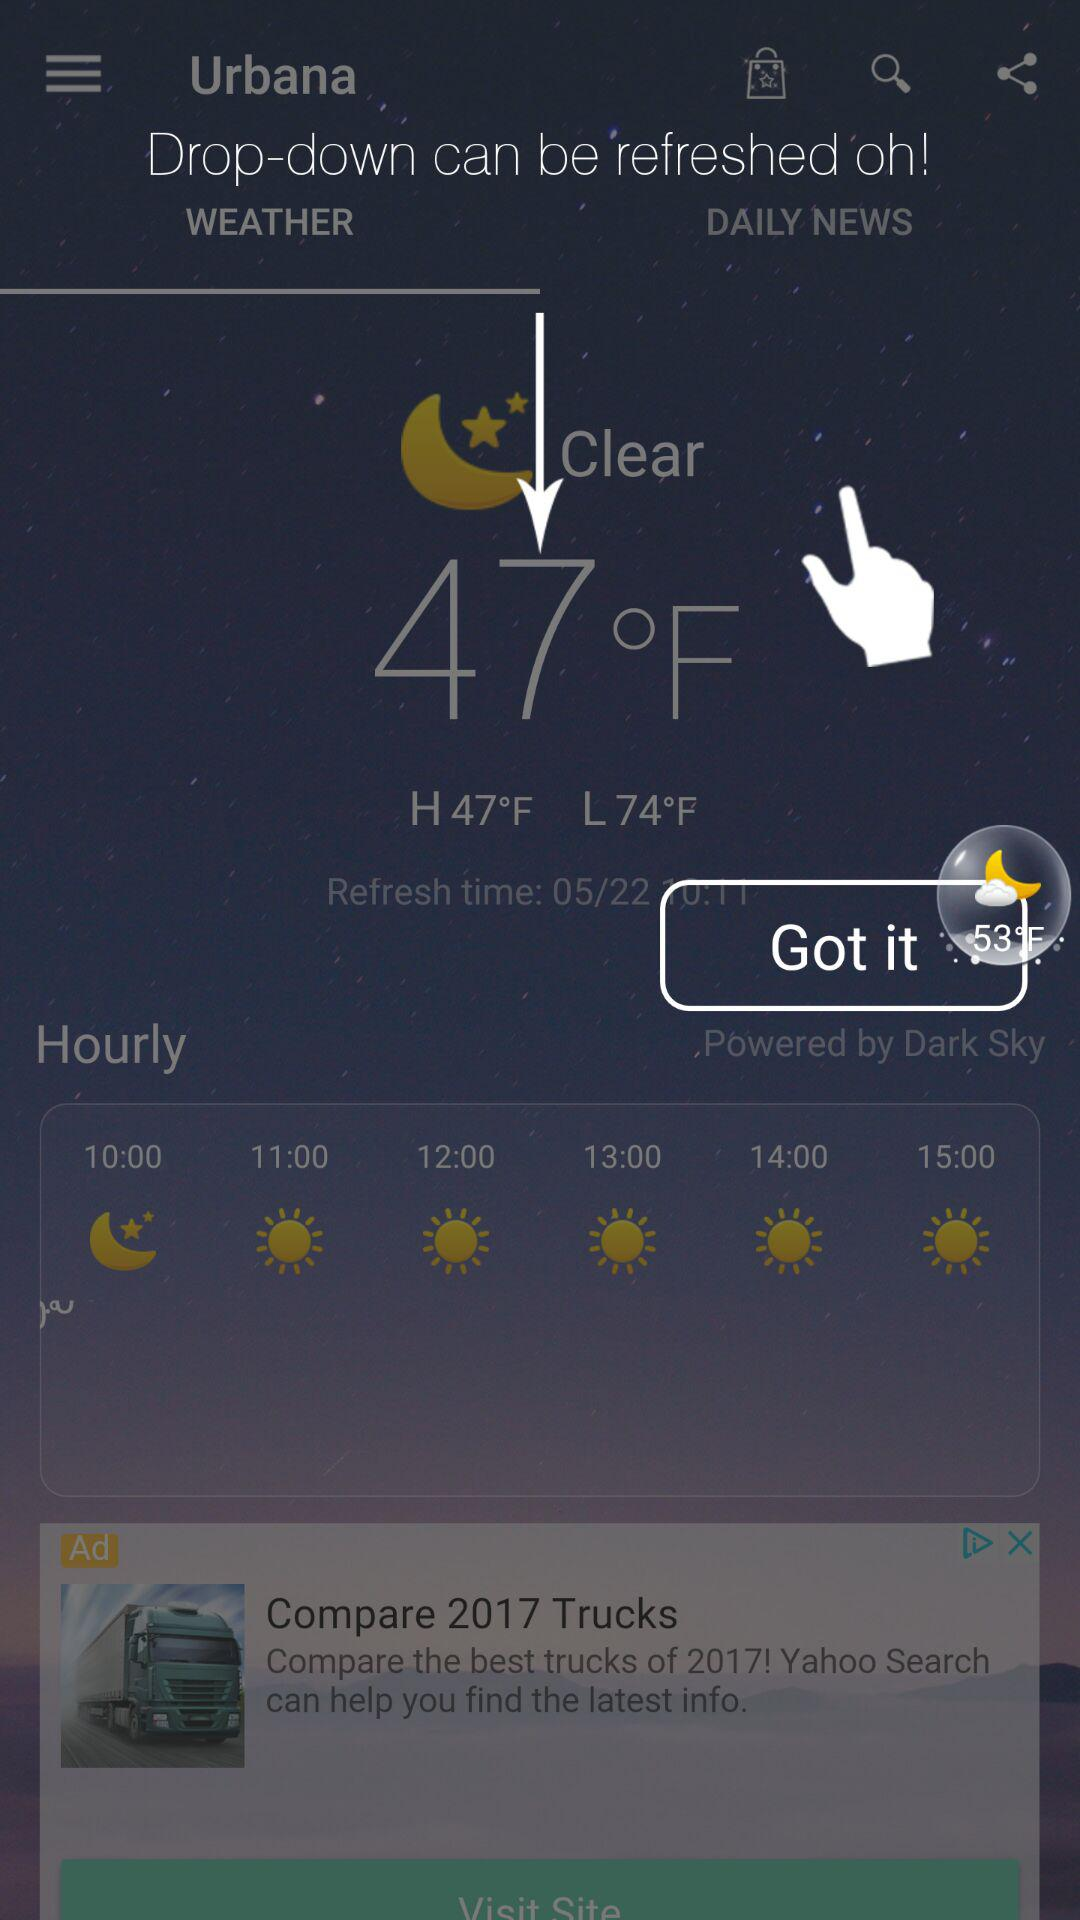What does the weather look like? The weather looks clear. 